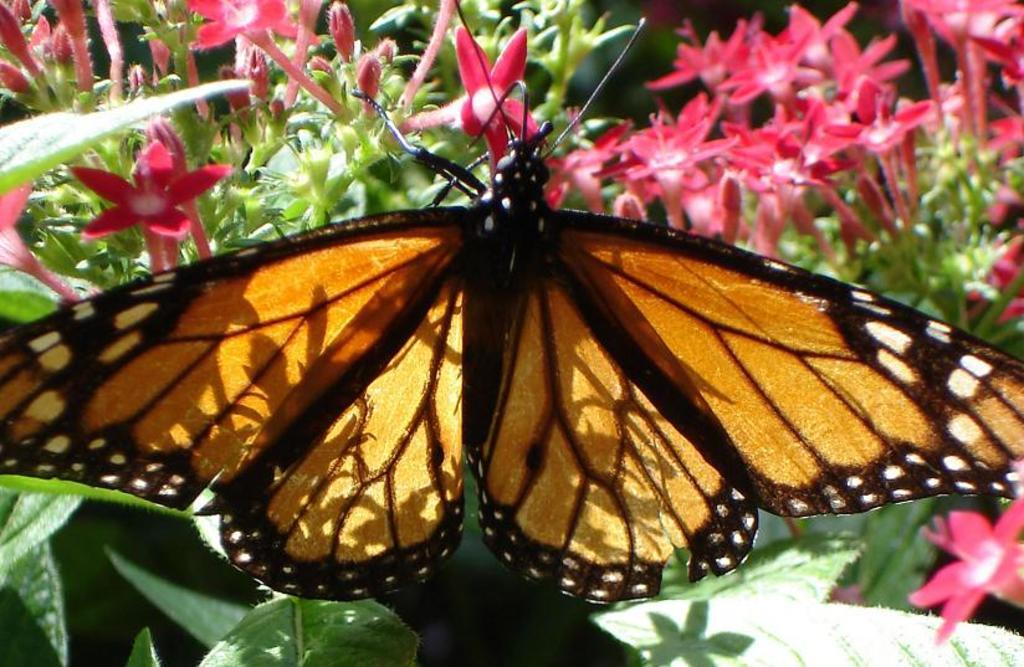What is the main subject of the image? There is a butterfly in the image. Where is the butterfly located? The butterfly is on a flower. What is the flower a part of? The flower is part of a plant. What can be seen in the background of the image? There is a group of leaves and flowers in the background of the image. What type of lumber is visible in the image? There is no lumber present in the image; it features a butterfly on a flower. Can you tell me how many mountains are in the background of the image? There are no mountains visible in the image; it features a group of leaves and flowers in the background. 